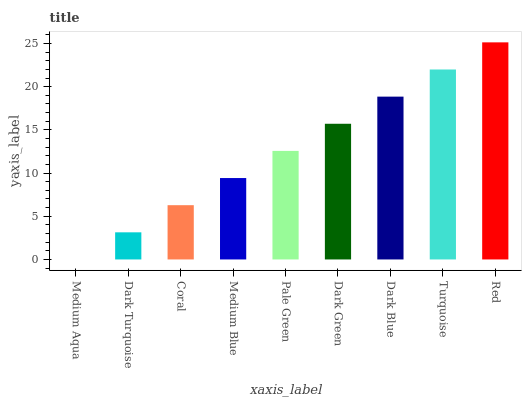Is Dark Turquoise the minimum?
Answer yes or no. No. Is Dark Turquoise the maximum?
Answer yes or no. No. Is Dark Turquoise greater than Medium Aqua?
Answer yes or no. Yes. Is Medium Aqua less than Dark Turquoise?
Answer yes or no. Yes. Is Medium Aqua greater than Dark Turquoise?
Answer yes or no. No. Is Dark Turquoise less than Medium Aqua?
Answer yes or no. No. Is Pale Green the high median?
Answer yes or no. Yes. Is Pale Green the low median?
Answer yes or no. Yes. Is Medium Aqua the high median?
Answer yes or no. No. Is Dark Blue the low median?
Answer yes or no. No. 